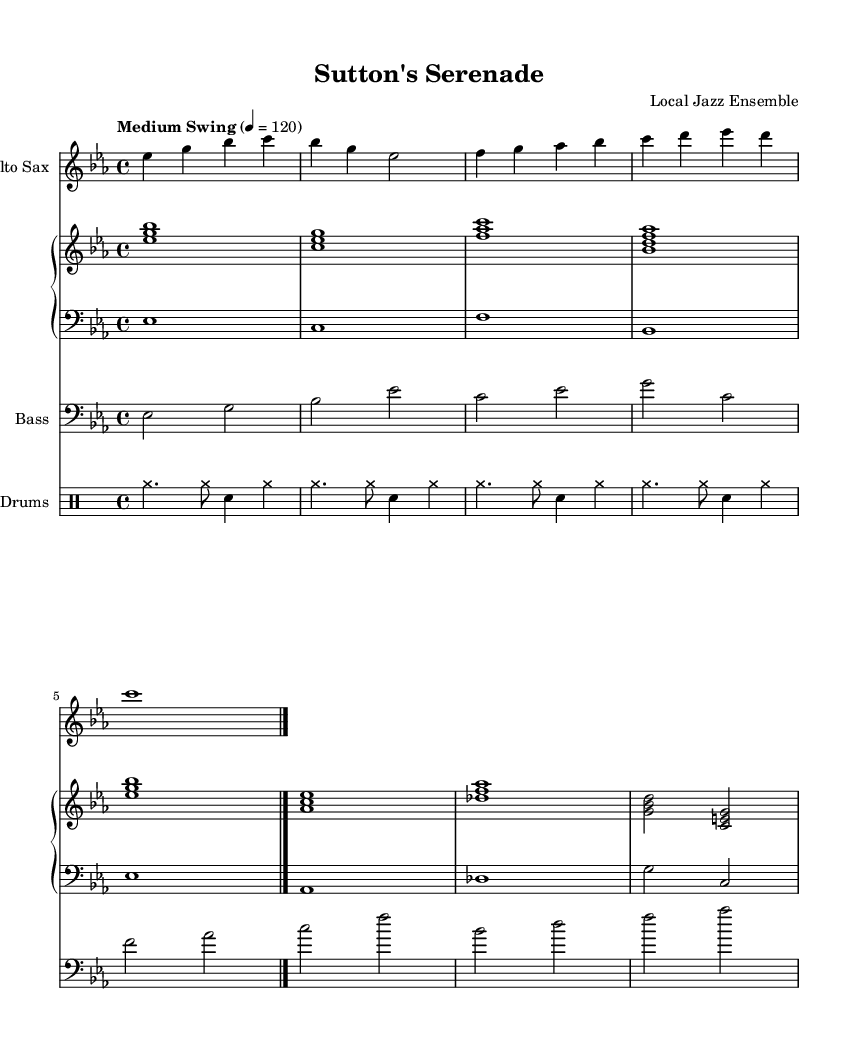What is the key signature of this music? The key signature is E flat major, which includes three flat notes: B flat, E flat, and A flat. This can be identified at the beginning of the score where the key signature is represented with flat symbols on the staff.
Answer: E flat major What is the time signature of this music? The time signature is 4/4, which means there are four beats in each measure and the quarter note gets one beat. This can be recognized in the top part of the sheet music where the time signature is displayed.
Answer: 4/4 What is the tempo marking of this piece? The tempo marking states "Medium Swing" with a metronome marking of 120 beats per minute. This indicates how fast the piece should be played, providing the musicians with a guideline for the overall feel. This information appears prominently below the clef and key signature.
Answer: Medium Swing How many measures are there in the saxophone part? There are 5 measures in the saxophone part, as indicated by the distinct separation of music notation between the vertical lines on the staff. Each measure is counted individually until the double bar line is reached at the end.
Answer: 5 What is the form of this jazz arrangement? The arrangement follows a standard AABA form structure commonly found in jazz music, where the A sections present the main theme and the B section contrasts with it. This is implied by the repeating patterns and thematic material in the written notes.
Answer: AABA Which instruments are included in the ensemble? The ensemble consists of four distinct instruments: alto saxophone, piano (with right-hand and left-hand notation), bass, and drums. This is easily identified by the specific staves for each instrument labeled clearly at the beginning of the staff.
Answer: Alto Saxophone, Piano, Bass, Drums 